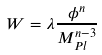Convert formula to latex. <formula><loc_0><loc_0><loc_500><loc_500>W = \lambda { \frac { \phi ^ { n } } { M _ { P l } ^ { n - 3 } } }</formula> 